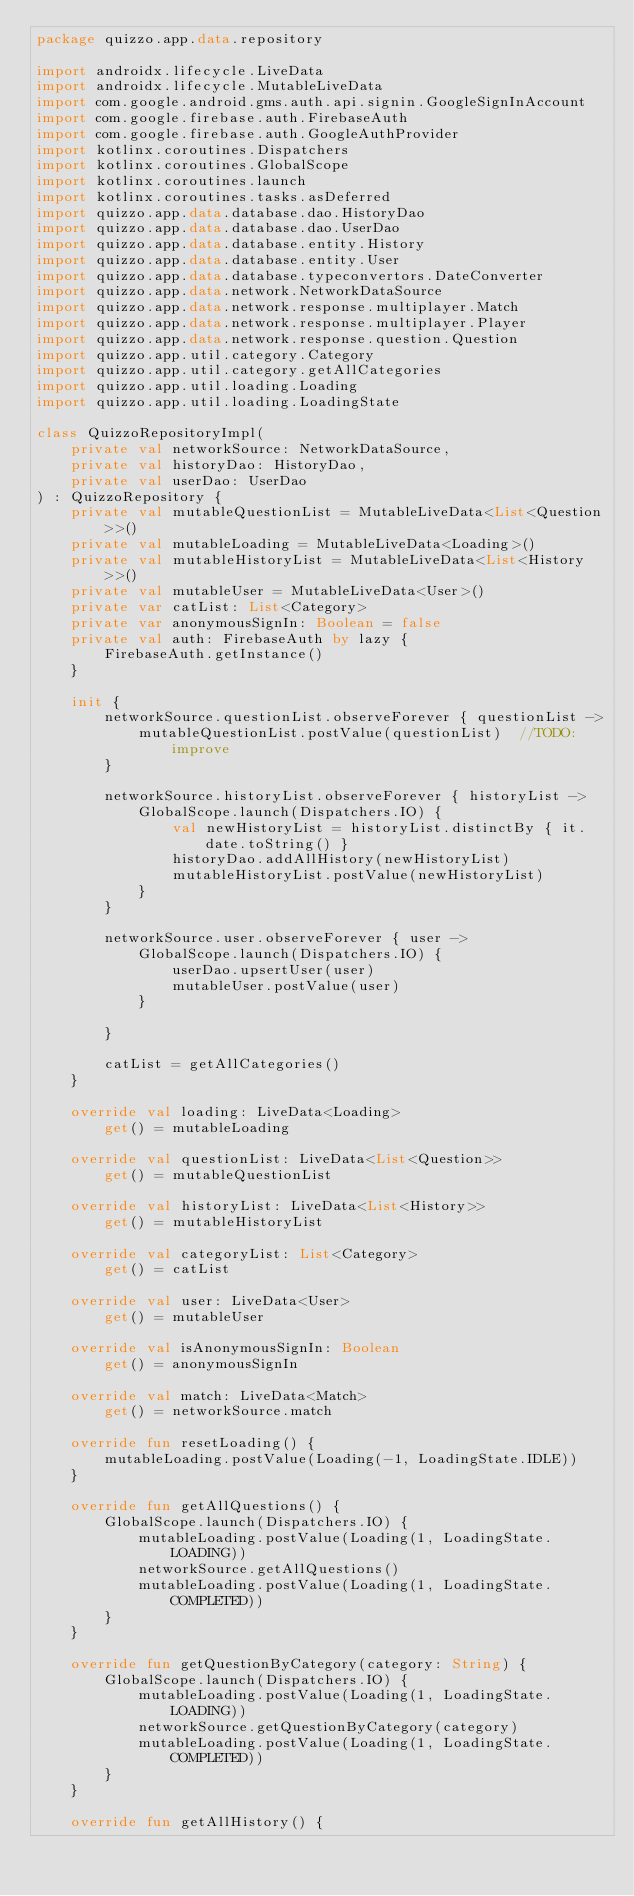<code> <loc_0><loc_0><loc_500><loc_500><_Kotlin_>package quizzo.app.data.repository

import androidx.lifecycle.LiveData
import androidx.lifecycle.MutableLiveData
import com.google.android.gms.auth.api.signin.GoogleSignInAccount
import com.google.firebase.auth.FirebaseAuth
import com.google.firebase.auth.GoogleAuthProvider
import kotlinx.coroutines.Dispatchers
import kotlinx.coroutines.GlobalScope
import kotlinx.coroutines.launch
import kotlinx.coroutines.tasks.asDeferred
import quizzo.app.data.database.dao.HistoryDao
import quizzo.app.data.database.dao.UserDao
import quizzo.app.data.database.entity.History
import quizzo.app.data.database.entity.User
import quizzo.app.data.database.typeconvertors.DateConverter
import quizzo.app.data.network.NetworkDataSource
import quizzo.app.data.network.response.multiplayer.Match
import quizzo.app.data.network.response.multiplayer.Player
import quizzo.app.data.network.response.question.Question
import quizzo.app.util.category.Category
import quizzo.app.util.category.getAllCategories
import quizzo.app.util.loading.Loading
import quizzo.app.util.loading.LoadingState

class QuizzoRepositoryImpl(
    private val networkSource: NetworkDataSource,
    private val historyDao: HistoryDao,
    private val userDao: UserDao
) : QuizzoRepository {
    private val mutableQuestionList = MutableLiveData<List<Question>>()
    private val mutableLoading = MutableLiveData<Loading>()
    private val mutableHistoryList = MutableLiveData<List<History>>()
    private val mutableUser = MutableLiveData<User>()
    private var catList: List<Category>
    private var anonymousSignIn: Boolean = false
    private val auth: FirebaseAuth by lazy {
        FirebaseAuth.getInstance()
    }

    init {
        networkSource.questionList.observeForever { questionList ->
            mutableQuestionList.postValue(questionList)  //TODO: improve
        }

        networkSource.historyList.observeForever { historyList ->
            GlobalScope.launch(Dispatchers.IO) {
                val newHistoryList = historyList.distinctBy { it.date.toString() }
                historyDao.addAllHistory(newHistoryList)
                mutableHistoryList.postValue(newHistoryList)
            }
        }

        networkSource.user.observeForever { user ->
            GlobalScope.launch(Dispatchers.IO) {
                userDao.upsertUser(user)
                mutableUser.postValue(user)
            }

        }

        catList = getAllCategories()
    }

    override val loading: LiveData<Loading>
        get() = mutableLoading

    override val questionList: LiveData<List<Question>>
        get() = mutableQuestionList

    override val historyList: LiveData<List<History>>
        get() = mutableHistoryList

    override val categoryList: List<Category>
        get() = catList

    override val user: LiveData<User>
        get() = mutableUser

    override val isAnonymousSignIn: Boolean
        get() = anonymousSignIn

    override val match: LiveData<Match>
        get() = networkSource.match

    override fun resetLoading() {
        mutableLoading.postValue(Loading(-1, LoadingState.IDLE))
    }

    override fun getAllQuestions() {
        GlobalScope.launch(Dispatchers.IO) {
            mutableLoading.postValue(Loading(1, LoadingState.LOADING))
            networkSource.getAllQuestions()
            mutableLoading.postValue(Loading(1, LoadingState.COMPLETED))
        }
    }

    override fun getQuestionByCategory(category: String) {
        GlobalScope.launch(Dispatchers.IO) {
            mutableLoading.postValue(Loading(1, LoadingState.LOADING))
            networkSource.getQuestionByCategory(category)
            mutableLoading.postValue(Loading(1, LoadingState.COMPLETED))
        }
    }

    override fun getAllHistory() {</code> 